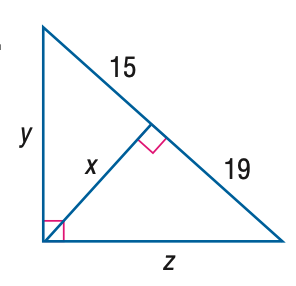Answer the mathemtical geometry problem and directly provide the correct option letter.
Question: Find y.
Choices: A: \sqrt { 285 } B: \sqrt { 510 } C: 2 \sqrt { 285 } D: 2 \sqrt { 510 } B 